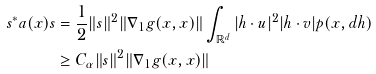Convert formula to latex. <formula><loc_0><loc_0><loc_500><loc_500>s ^ { * } a ( x ) s & = \frac { 1 } { 2 } \| s \| ^ { 2 } \| \nabla _ { 1 } g ( x , x ) \| \int _ { \mathbb { R } ^ { d } } | h \cdot u | ^ { 2 } | h \cdot v | p ( x , d h ) \\ & \geq C _ { \alpha } \| s \| ^ { 2 } \| \nabla _ { 1 } g ( x , x ) \|</formula> 